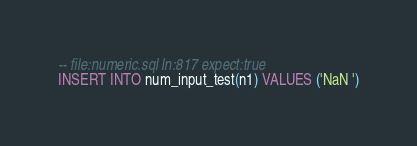Convert code to text. <code><loc_0><loc_0><loc_500><loc_500><_SQL_>-- file:numeric.sql ln:817 expect:true
INSERT INTO num_input_test(n1) VALUES ('NaN ')
</code> 